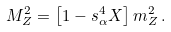<formula> <loc_0><loc_0><loc_500><loc_500>M _ { Z } ^ { 2 } = \left [ 1 - s _ { \alpha } ^ { 4 } X \right ] m _ { Z } ^ { 2 } \, .</formula> 